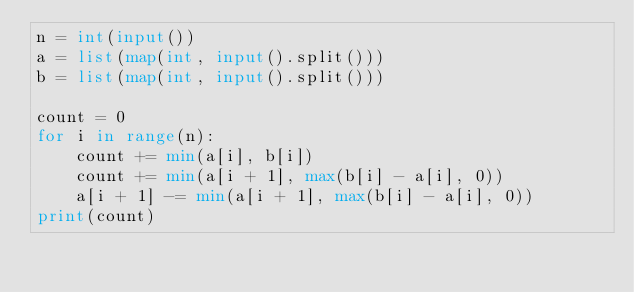Convert code to text. <code><loc_0><loc_0><loc_500><loc_500><_Python_>n = int(input())
a = list(map(int, input().split()))
b = list(map(int, input().split()))

count = 0
for i in range(n):
    count += min(a[i], b[i])
    count += min(a[i + 1], max(b[i] - a[i], 0))
    a[i + 1] -= min(a[i + 1], max(b[i] - a[i], 0))
print(count)</code> 